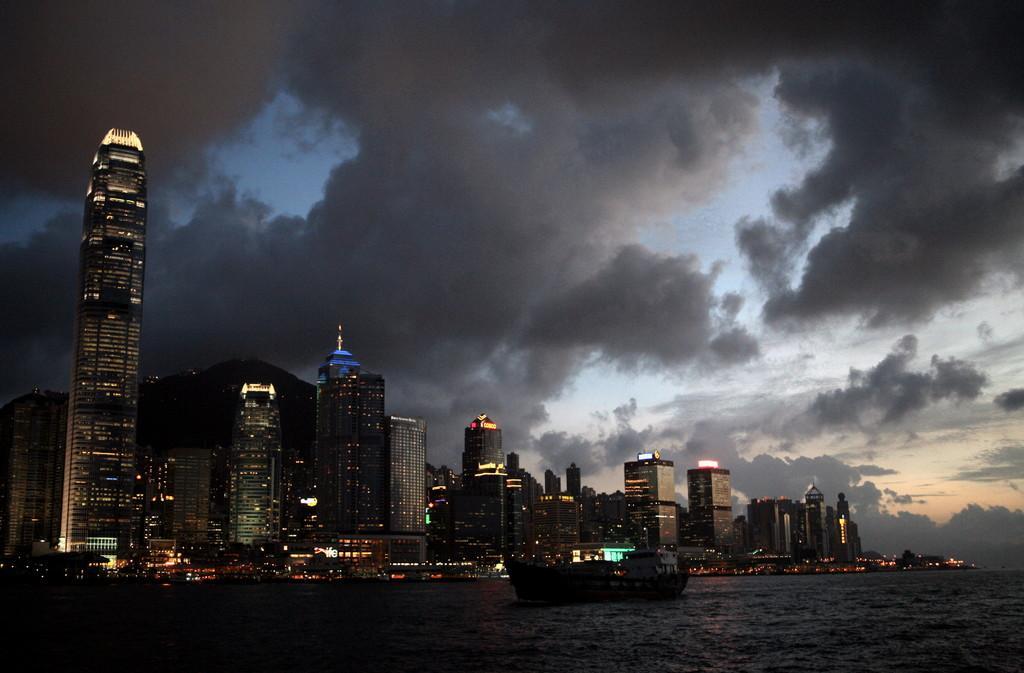How would you summarize this image in a sentence or two? In this picture, we can see a few building with windows, lights, water, boats, and the sky with clouds. 